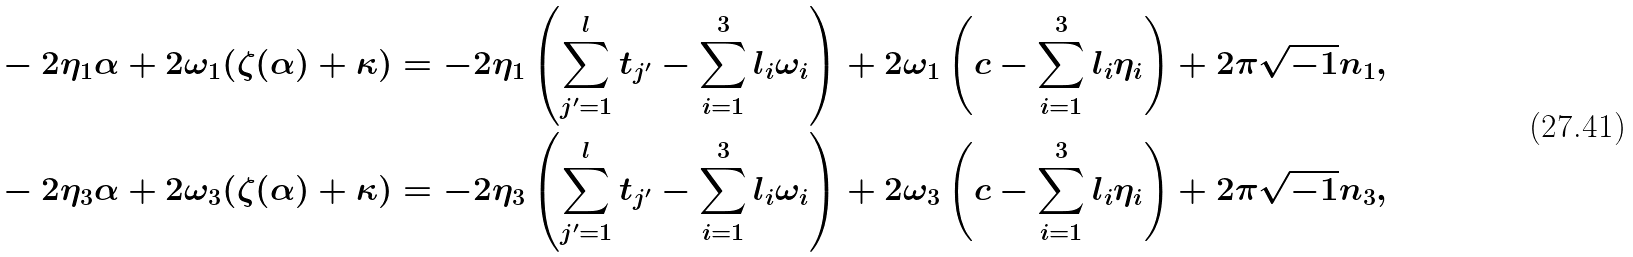<formula> <loc_0><loc_0><loc_500><loc_500>& - 2 \eta _ { 1 } \alpha + 2 \omega _ { 1 } ( \zeta ( \alpha ) + \kappa ) = - 2 \eta _ { 1 } \left ( \sum _ { j ^ { \prime } = 1 } ^ { l } t _ { j ^ { \prime } } - \sum _ { i = 1 } ^ { 3 } l _ { i } \omega _ { i } \right ) + 2 \omega _ { 1 } \left ( c - \sum _ { i = 1 } ^ { 3 } l _ { i } \eta _ { i } \right ) + 2 \pi \sqrt { - 1 } n _ { 1 } , \\ & - 2 \eta _ { 3 } \alpha + 2 \omega _ { 3 } ( \zeta ( \alpha ) + \kappa ) = - 2 \eta _ { 3 } \left ( \sum _ { j ^ { \prime } = 1 } ^ { l } t _ { j ^ { \prime } } - \sum _ { i = 1 } ^ { 3 } l _ { i } \omega _ { i } \right ) + 2 \omega _ { 3 } \left ( c - \sum _ { i = 1 } ^ { 3 } l _ { i } \eta _ { i } \right ) + 2 \pi \sqrt { - 1 } n _ { 3 } ,</formula> 